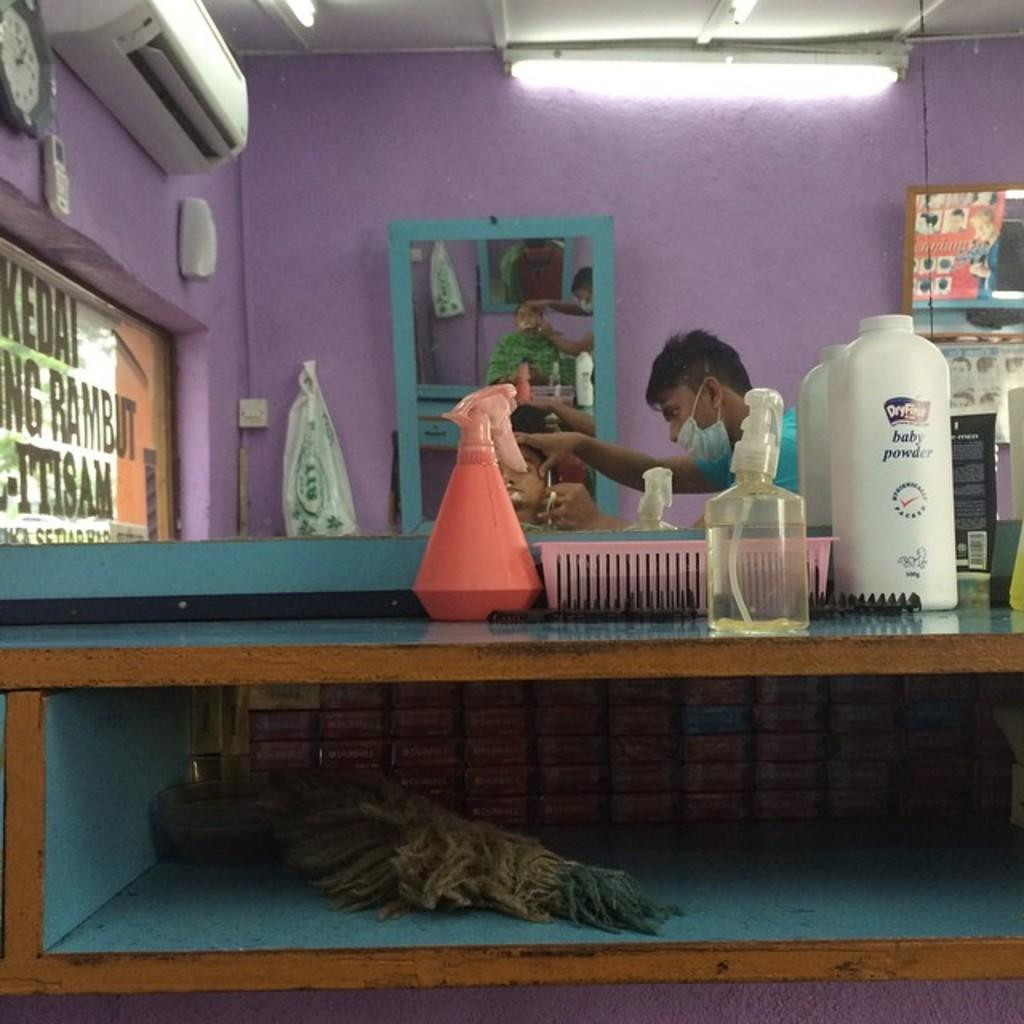Provide a one-sentence caption for the provided image. Baby powder and some spray bottles sit on a shelf in a barbershop. 